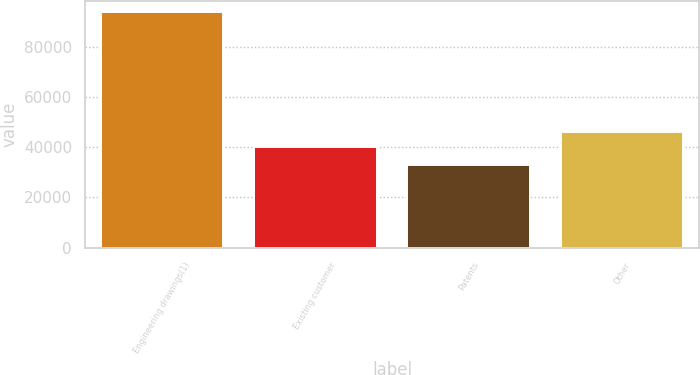Convert chart to OTSL. <chart><loc_0><loc_0><loc_500><loc_500><bar_chart><fcel>Engineering drawings(1)<fcel>Existing customer<fcel>Patents<fcel>Other<nl><fcel>93687<fcel>40077<fcel>32963<fcel>46149.4<nl></chart> 